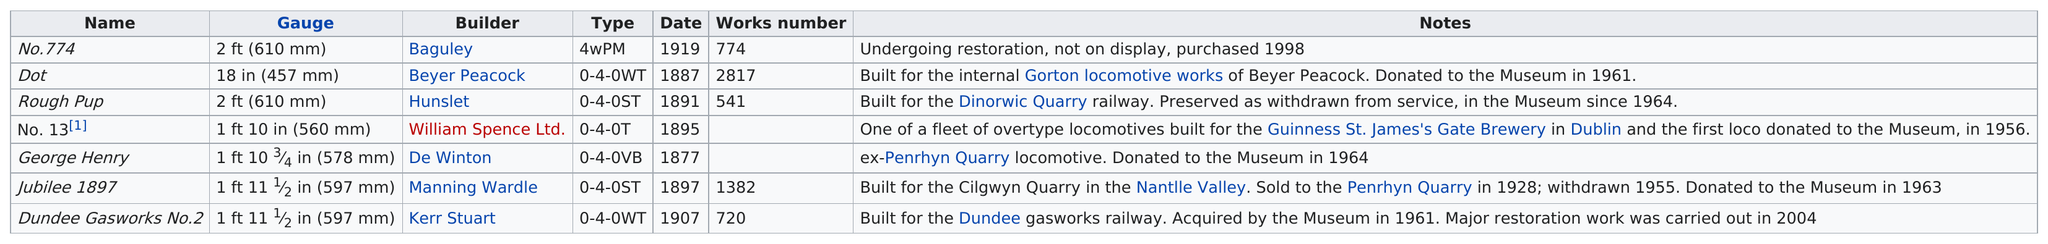Give some essential details in this illustration. Seven locomotives are currently on display at the narrow gauge railway museum. The name that comes before the 'dot' in the number 'No.774..' is 'No.774..'. The first locomotive produced at the museum is named George Henry. Based on the table, it can be determined that George Henry was the first locomotive to be built. The locomotive that was built after 1915 is No. 774. 